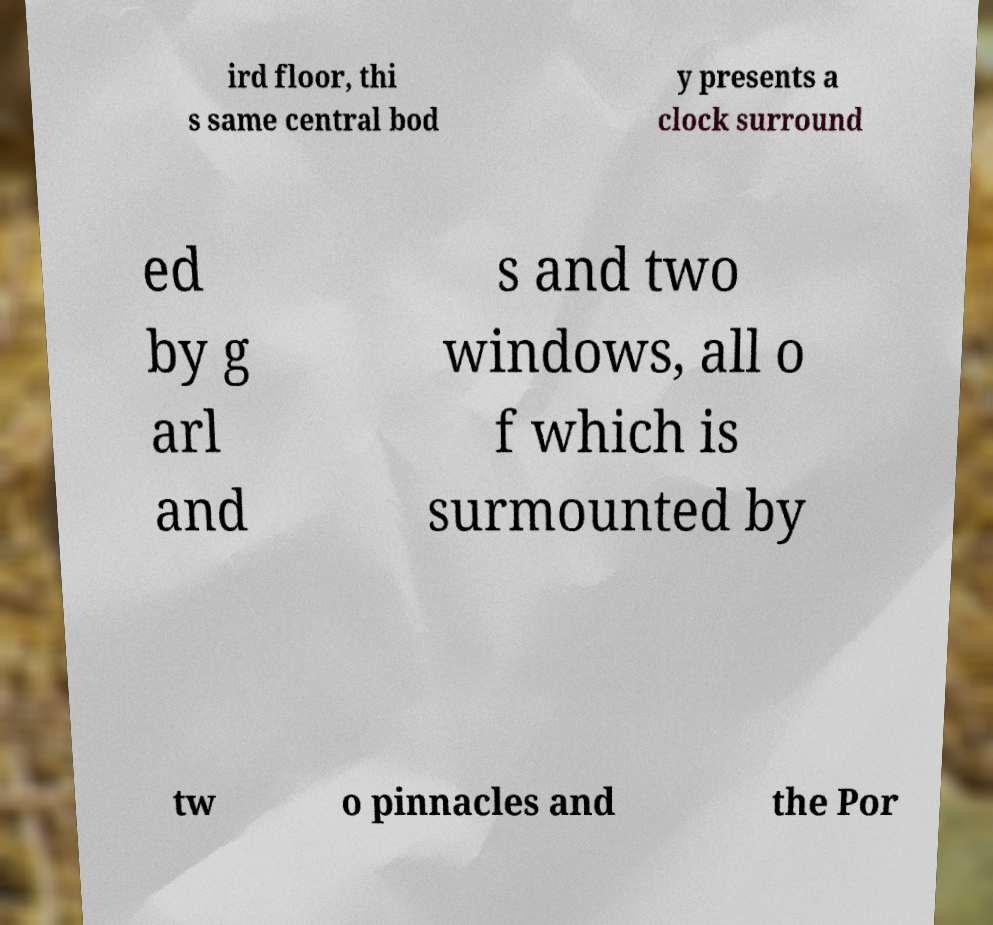For documentation purposes, I need the text within this image transcribed. Could you provide that? ird floor, thi s same central bod y presents a clock surround ed by g arl and s and two windows, all o f which is surmounted by tw o pinnacles and the Por 